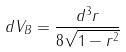Convert formula to latex. <formula><loc_0><loc_0><loc_500><loc_500>d V _ { B } = \frac { d ^ { 3 } r } { 8 \sqrt { 1 - r ^ { 2 } } }</formula> 